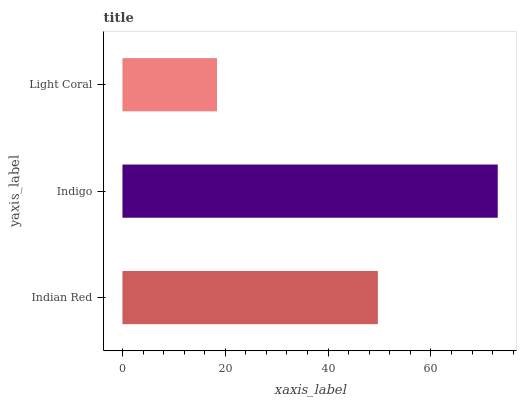Is Light Coral the minimum?
Answer yes or no. Yes. Is Indigo the maximum?
Answer yes or no. Yes. Is Indigo the minimum?
Answer yes or no. No. Is Light Coral the maximum?
Answer yes or no. No. Is Indigo greater than Light Coral?
Answer yes or no. Yes. Is Light Coral less than Indigo?
Answer yes or no. Yes. Is Light Coral greater than Indigo?
Answer yes or no. No. Is Indigo less than Light Coral?
Answer yes or no. No. Is Indian Red the high median?
Answer yes or no. Yes. Is Indian Red the low median?
Answer yes or no. Yes. Is Light Coral the high median?
Answer yes or no. No. Is Indigo the low median?
Answer yes or no. No. 